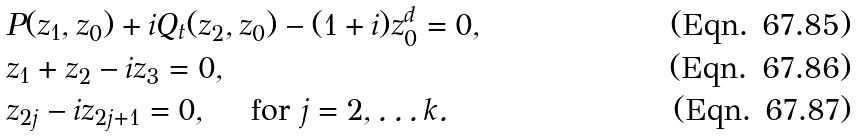<formula> <loc_0><loc_0><loc_500><loc_500>& P ( z _ { 1 } , z _ { 0 } ) + i Q _ { t } ( z _ { 2 } , z _ { 0 } ) - ( 1 + i ) z _ { 0 } ^ { d } = 0 , \\ & z _ { 1 } + z _ { 2 } - i z _ { 3 } = 0 , \\ & z _ { 2 j } - i z _ { 2 j + 1 } = 0 , \quad \text { for } j = 2 , \dots k .</formula> 